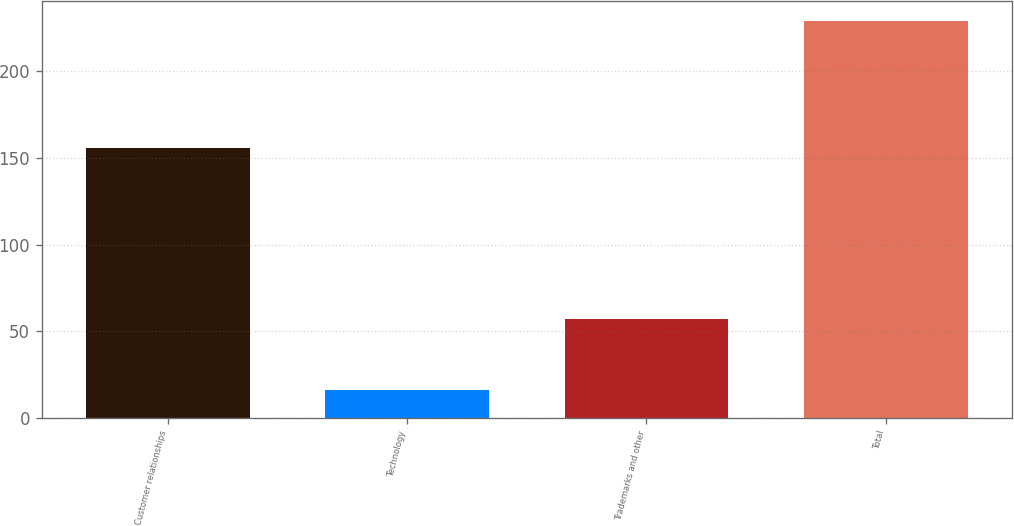Convert chart to OTSL. <chart><loc_0><loc_0><loc_500><loc_500><bar_chart><fcel>Customer relationships<fcel>Technology<fcel>Trademarks and other<fcel>Total<nl><fcel>156<fcel>16<fcel>57<fcel>229<nl></chart> 